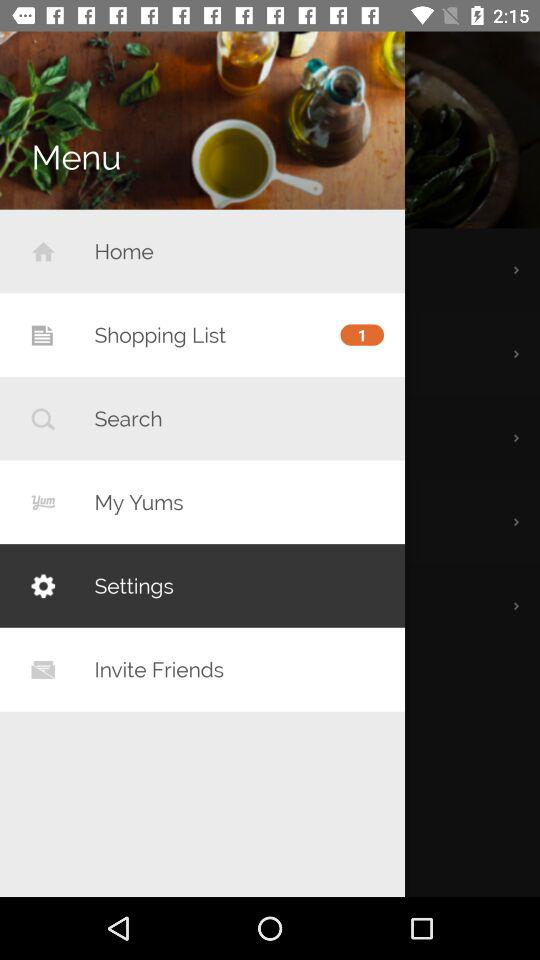How many notifications are pending in "Shopping List"? There is 1 notification pending in "Shopping List". 